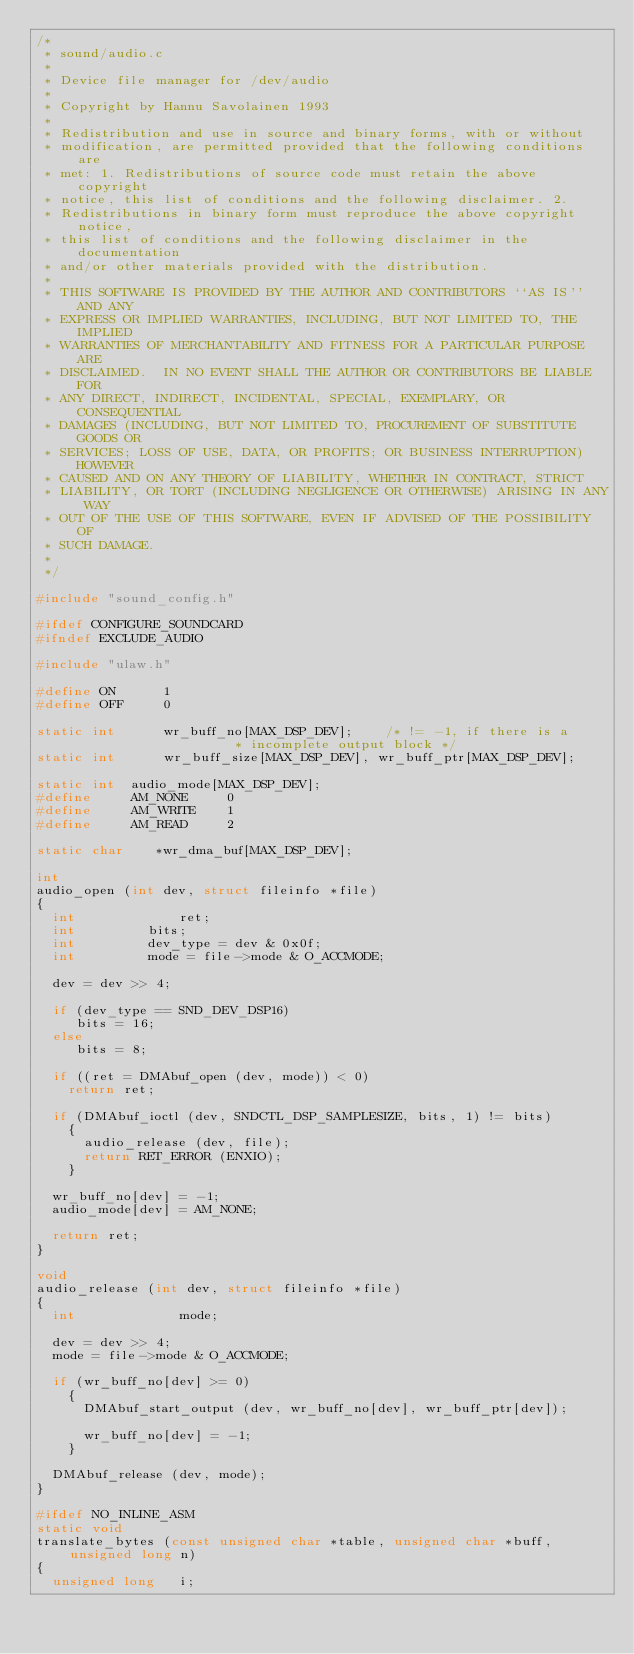Convert code to text. <code><loc_0><loc_0><loc_500><loc_500><_C_>/*
 * sound/audio.c
 * 
 * Device file manager for /dev/audio
 * 
 * Copyright by Hannu Savolainen 1993
 * 
 * Redistribution and use in source and binary forms, with or without
 * modification, are permitted provided that the following conditions are
 * met: 1. Redistributions of source code must retain the above copyright
 * notice, this list of conditions and the following disclaimer. 2.
 * Redistributions in binary form must reproduce the above copyright notice,
 * this list of conditions and the following disclaimer in the documentation
 * and/or other materials provided with the distribution.
 * 
 * THIS SOFTWARE IS PROVIDED BY THE AUTHOR AND CONTRIBUTORS ``AS IS'' AND ANY
 * EXPRESS OR IMPLIED WARRANTIES, INCLUDING, BUT NOT LIMITED TO, THE IMPLIED
 * WARRANTIES OF MERCHANTABILITY AND FITNESS FOR A PARTICULAR PURPOSE ARE
 * DISCLAIMED.  IN NO EVENT SHALL THE AUTHOR OR CONTRIBUTORS BE LIABLE FOR
 * ANY DIRECT, INDIRECT, INCIDENTAL, SPECIAL, EXEMPLARY, OR CONSEQUENTIAL
 * DAMAGES (INCLUDING, BUT NOT LIMITED TO, PROCUREMENT OF SUBSTITUTE GOODS OR
 * SERVICES; LOSS OF USE, DATA, OR PROFITS; OR BUSINESS INTERRUPTION) HOWEVER
 * CAUSED AND ON ANY THEORY OF LIABILITY, WHETHER IN CONTRACT, STRICT
 * LIABILITY, OR TORT (INCLUDING NEGLIGENCE OR OTHERWISE) ARISING IN ANY WAY
 * OUT OF THE USE OF THIS SOFTWARE, EVEN IF ADVISED OF THE POSSIBILITY OF
 * SUCH DAMAGE.
 * 
 */

#include "sound_config.h"

#ifdef CONFIGURE_SOUNDCARD
#ifndef EXCLUDE_AUDIO

#include "ulaw.h"

#define ON		1
#define OFF		0

static int      wr_buff_no[MAX_DSP_DEV];	/* != -1, if there is a
						 * incomplete output block */
static int      wr_buff_size[MAX_DSP_DEV], wr_buff_ptr[MAX_DSP_DEV];

static int	audio_mode[MAX_DSP_DEV];
#define		AM_NONE		0
#define		AM_WRITE	1
#define 	AM_READ		2

static char    *wr_dma_buf[MAX_DSP_DEV];

int
audio_open (int dev, struct fileinfo *file)
{
  int             ret;
  int		  bits;
  int		  dev_type = dev & 0x0f;
  int		  mode = file->mode & O_ACCMODE;

  dev = dev >> 4;

  if (dev_type == SND_DEV_DSP16)
     bits = 16;
  else
     bits = 8;

  if ((ret = DMAbuf_open (dev, mode)) < 0)
    return ret;

  if (DMAbuf_ioctl (dev, SNDCTL_DSP_SAMPLESIZE, bits, 1) != bits)
    {
      audio_release (dev, file);
      return RET_ERROR (ENXIO);
    }

  wr_buff_no[dev] = -1;
  audio_mode[dev] = AM_NONE;

  return ret;
}

void
audio_release (int dev, struct fileinfo *file)
{
  int             mode;

  dev = dev >> 4;
  mode = file->mode & O_ACCMODE;

  if (wr_buff_no[dev] >= 0)
    {
      DMAbuf_start_output (dev, wr_buff_no[dev], wr_buff_ptr[dev]);

      wr_buff_no[dev] = -1;
    }

  DMAbuf_release (dev, mode);
}

#ifdef NO_INLINE_ASM
static void
translate_bytes (const unsigned char *table, unsigned char *buff, unsigned long n)
{
  unsigned long   i;
</code> 